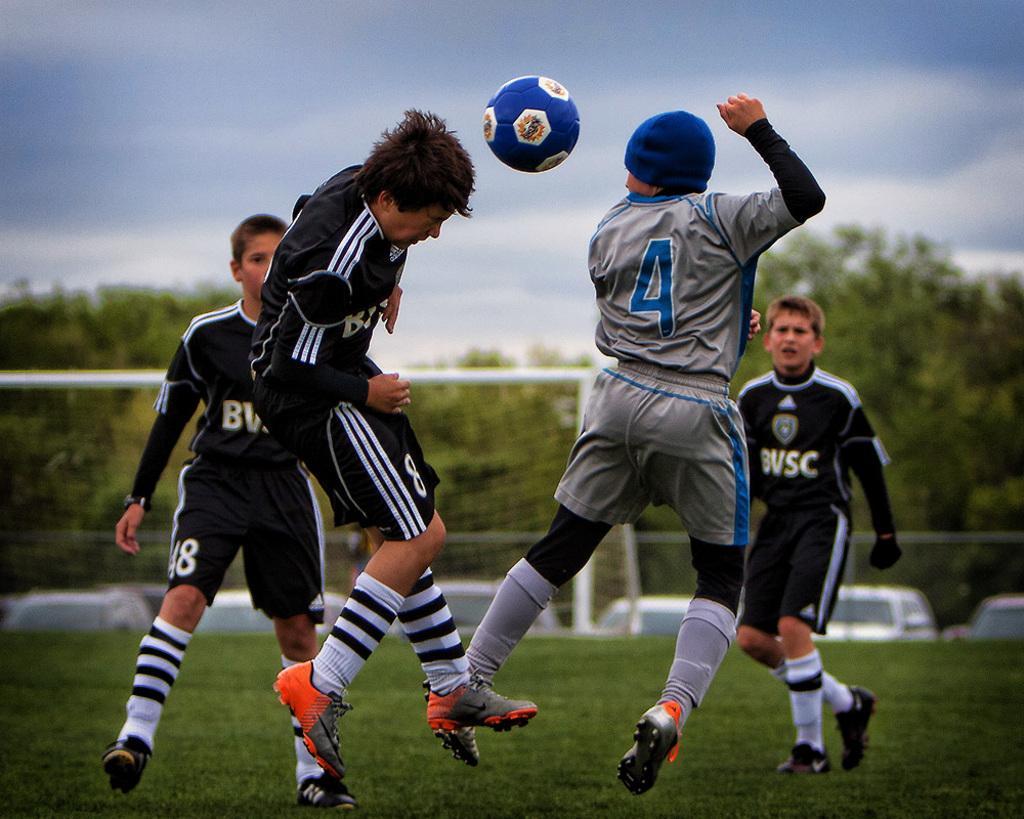In one or two sentences, can you explain what this image depicts? This image is taken in outdoors. There are four boys in this image. They are playing football In the ground. There is a wall in this image. In the bottom of the image there is a grass. At the background there are many trees and a football net and there are few vehicles. At the top of the image there is a sky with clouds. 